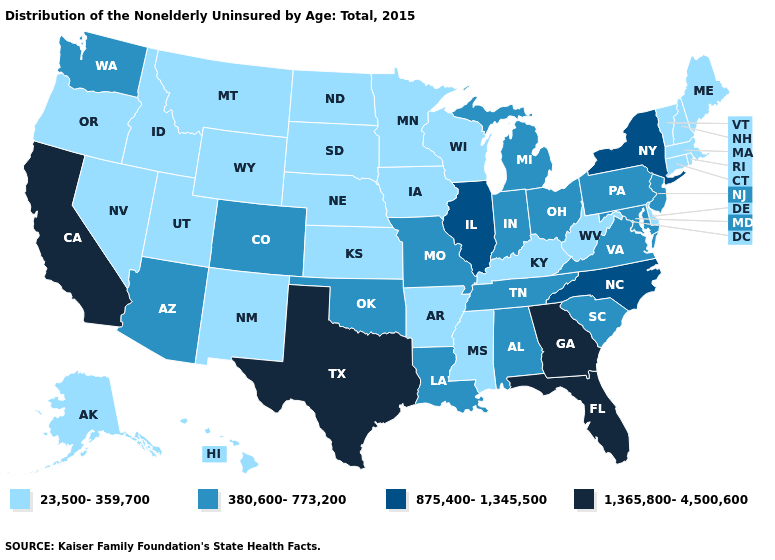Among the states that border New Jersey , which have the highest value?
Short answer required. New York. Name the states that have a value in the range 1,365,800-4,500,600?
Be succinct. California, Florida, Georgia, Texas. Does the map have missing data?
Be succinct. No. What is the highest value in the Northeast ?
Give a very brief answer. 875,400-1,345,500. What is the lowest value in the West?
Answer briefly. 23,500-359,700. Which states have the lowest value in the USA?
Write a very short answer. Alaska, Arkansas, Connecticut, Delaware, Hawaii, Idaho, Iowa, Kansas, Kentucky, Maine, Massachusetts, Minnesota, Mississippi, Montana, Nebraska, Nevada, New Hampshire, New Mexico, North Dakota, Oregon, Rhode Island, South Dakota, Utah, Vermont, West Virginia, Wisconsin, Wyoming. What is the highest value in states that border Minnesota?
Write a very short answer. 23,500-359,700. What is the lowest value in the USA?
Keep it brief. 23,500-359,700. Does the map have missing data?
Write a very short answer. No. Does Florida have the same value as California?
Be succinct. Yes. Name the states that have a value in the range 1,365,800-4,500,600?
Write a very short answer. California, Florida, Georgia, Texas. What is the value of Wisconsin?
Answer briefly. 23,500-359,700. Does Rhode Island have the same value as Pennsylvania?
Write a very short answer. No. Does the first symbol in the legend represent the smallest category?
Answer briefly. Yes. What is the value of Arkansas?
Quick response, please. 23,500-359,700. 